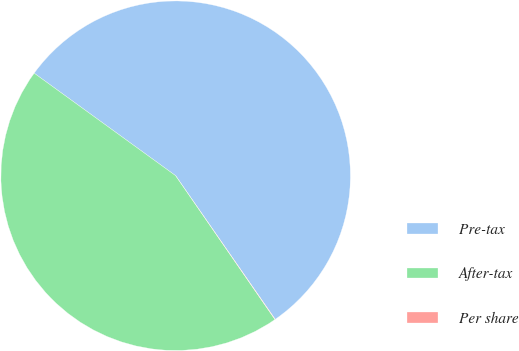Convert chart to OTSL. <chart><loc_0><loc_0><loc_500><loc_500><pie_chart><fcel>Pre-tax<fcel>After-tax<fcel>Per share<nl><fcel>55.37%<fcel>44.6%<fcel>0.03%<nl></chart> 